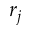<formula> <loc_0><loc_0><loc_500><loc_500>r _ { j }</formula> 